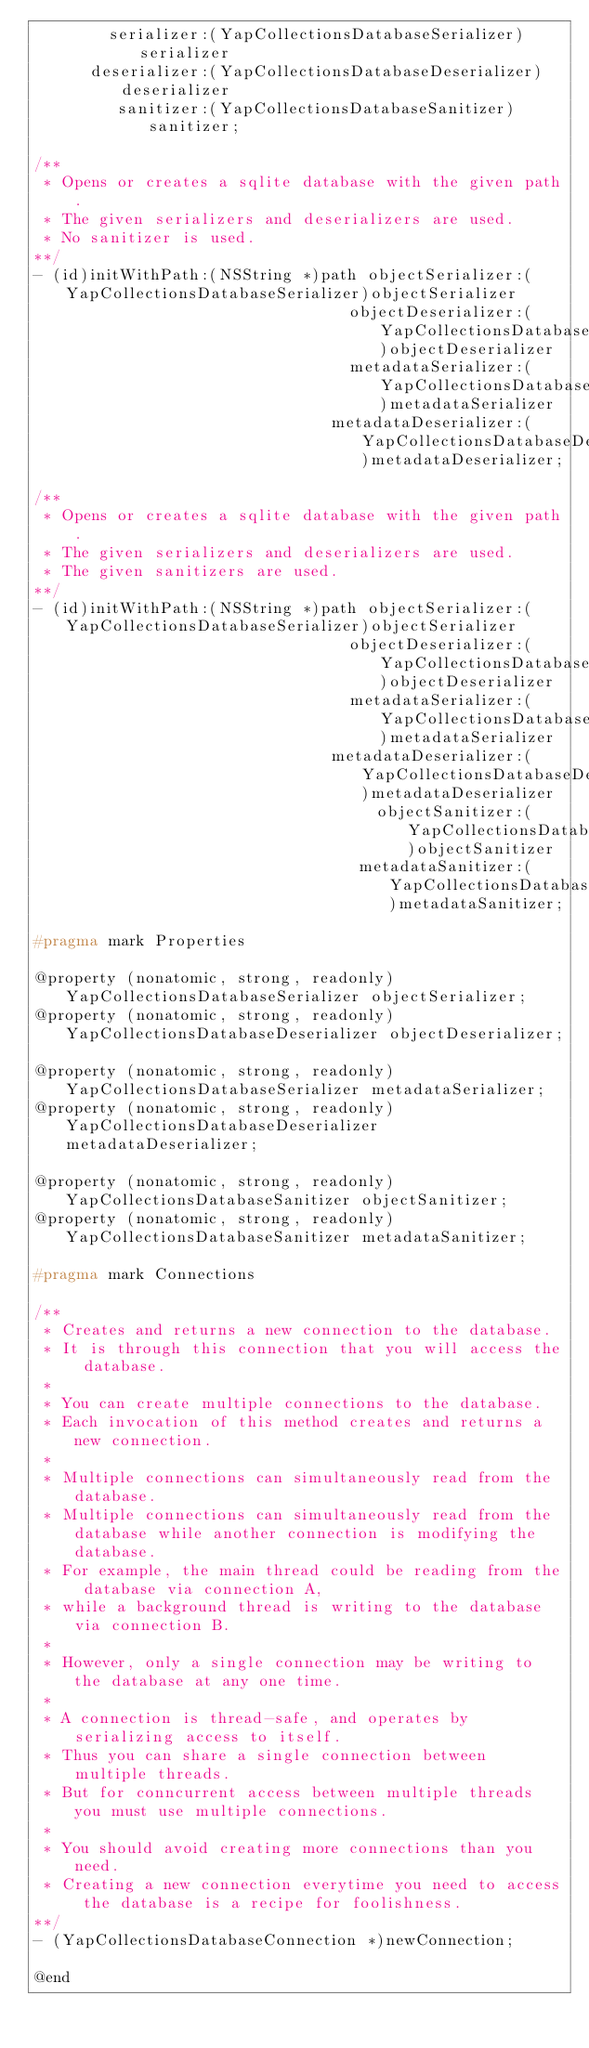Convert code to text. <code><loc_0><loc_0><loc_500><loc_500><_C_>        serializer:(YapCollectionsDatabaseSerializer)serializer
      deserializer:(YapCollectionsDatabaseDeserializer)deserializer
         sanitizer:(YapCollectionsDatabaseSanitizer)sanitizer;

/**
 * Opens or creates a sqlite database with the given path.
 * The given serializers and deserializers are used.
 * No sanitizer is used.
**/
- (id)initWithPath:(NSString *)path objectSerializer:(YapCollectionsDatabaseSerializer)objectSerializer
                                  objectDeserializer:(YapCollectionsDatabaseDeserializer)objectDeserializer
                                  metadataSerializer:(YapCollectionsDatabaseSerializer)metadataSerializer
                                metadataDeserializer:(YapCollectionsDatabaseDeserializer)metadataDeserializer;

/**
 * Opens or creates a sqlite database with the given path.
 * The given serializers and deserializers are used.
 * The given sanitizers are used.
**/
- (id)initWithPath:(NSString *)path objectSerializer:(YapCollectionsDatabaseSerializer)objectSerializer
                                  objectDeserializer:(YapCollectionsDatabaseDeserializer)objectDeserializer
                                  metadataSerializer:(YapCollectionsDatabaseSerializer)metadataSerializer
                                metadataDeserializer:(YapCollectionsDatabaseDeserializer)metadataDeserializer
                                     objectSanitizer:(YapCollectionsDatabaseSanitizer)objectSanitizer
                                   metadataSanitizer:(YapCollectionsDatabaseSanitizer)metadataSanitizer;

#pragma mark Properties

@property (nonatomic, strong, readonly) YapCollectionsDatabaseSerializer objectSerializer;
@property (nonatomic, strong, readonly) YapCollectionsDatabaseDeserializer objectDeserializer;

@property (nonatomic, strong, readonly) YapCollectionsDatabaseSerializer metadataSerializer;
@property (nonatomic, strong, readonly) YapCollectionsDatabaseDeserializer metadataDeserializer;

@property (nonatomic, strong, readonly) YapCollectionsDatabaseSanitizer objectSanitizer;
@property (nonatomic, strong, readonly) YapCollectionsDatabaseSanitizer metadataSanitizer;

#pragma mark Connections

/**
 * Creates and returns a new connection to the database.
 * It is through this connection that you will access the database.
 * 
 * You can create multiple connections to the database.
 * Each invocation of this method creates and returns a new connection.
 * 
 * Multiple connections can simultaneously read from the database.
 * Multiple connections can simultaneously read from the database while another connection is modifying the database.
 * For example, the main thread could be reading from the database via connection A,
 * while a background thread is writing to the database via connection B.
 * 
 * However, only a single connection may be writing to the database at any one time.
 *
 * A connection is thread-safe, and operates by serializing access to itself.
 * Thus you can share a single connection between multiple threads.
 * But for conncurrent access between multiple threads you must use multiple connections.
 *
 * You should avoid creating more connections than you need.
 * Creating a new connection everytime you need to access the database is a recipe for foolishness.
**/
- (YapCollectionsDatabaseConnection *)newConnection;

@end
</code> 